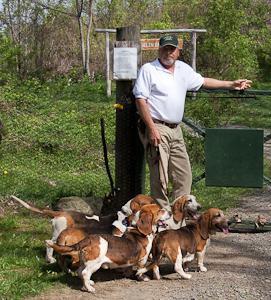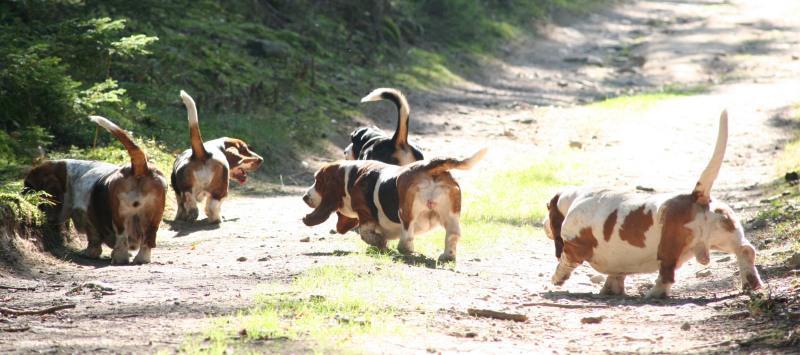The first image is the image on the left, the second image is the image on the right. Evaluate the accuracy of this statement regarding the images: "In one image, all the dogs are moving away from the camera and all the dogs are basset hounds.". Is it true? Answer yes or no. Yes. The first image is the image on the left, the second image is the image on the right. For the images shown, is this caption "There are four dogs outside in the image on the left." true? Answer yes or no. Yes. 